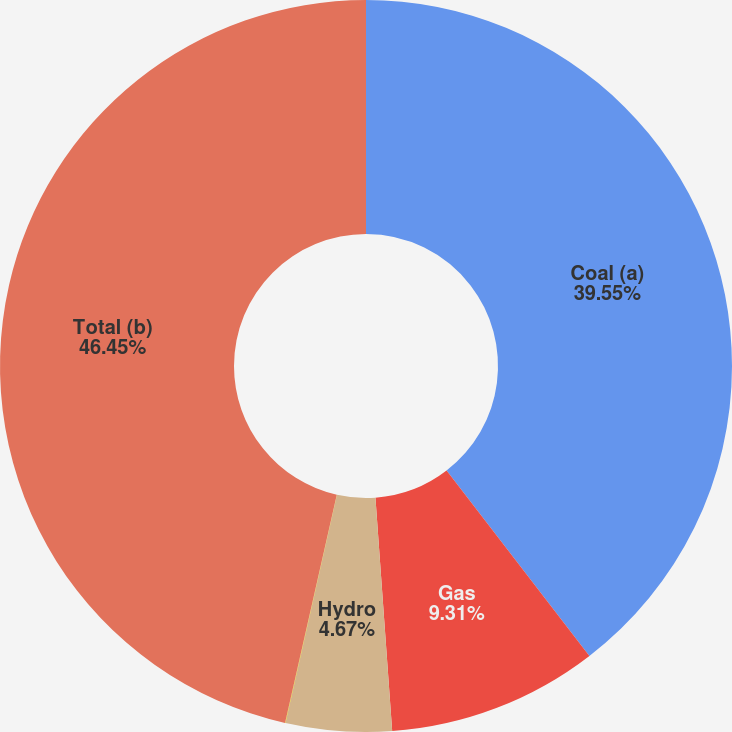Convert chart. <chart><loc_0><loc_0><loc_500><loc_500><pie_chart><fcel>Coal (a)<fcel>Gas<fcel>Hydro<fcel>Solar<fcel>Total (b)<nl><fcel>39.55%<fcel>9.31%<fcel>4.67%<fcel>0.02%<fcel>46.45%<nl></chart> 